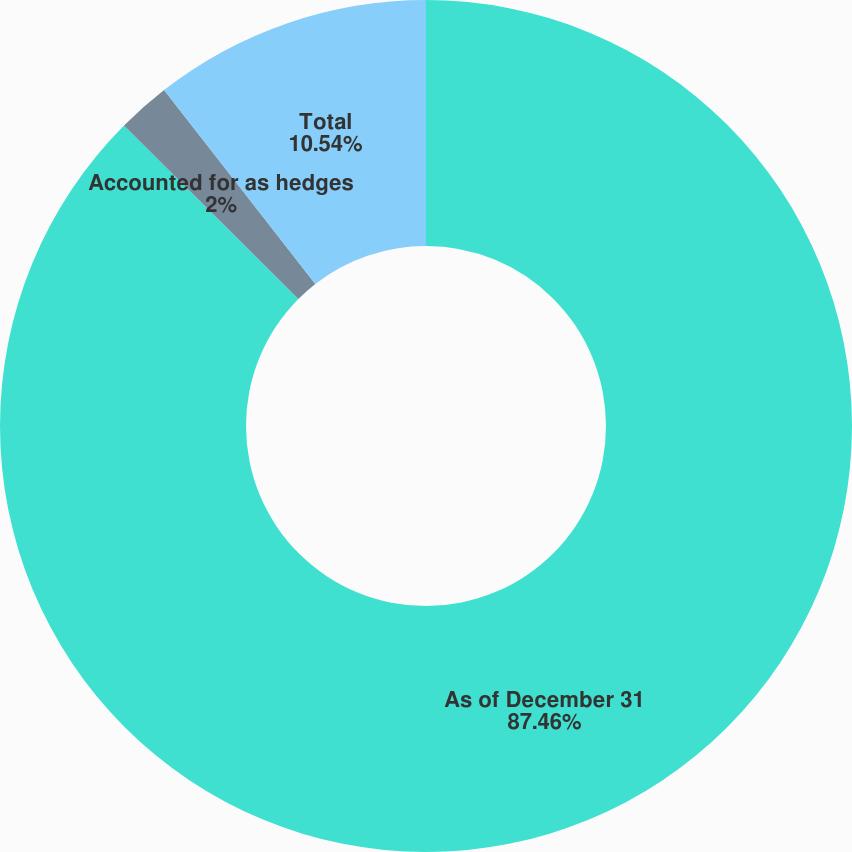Convert chart. <chart><loc_0><loc_0><loc_500><loc_500><pie_chart><fcel>As of December 31<fcel>Accounted for as hedges<fcel>Total<nl><fcel>87.46%<fcel>2.0%<fcel>10.54%<nl></chart> 